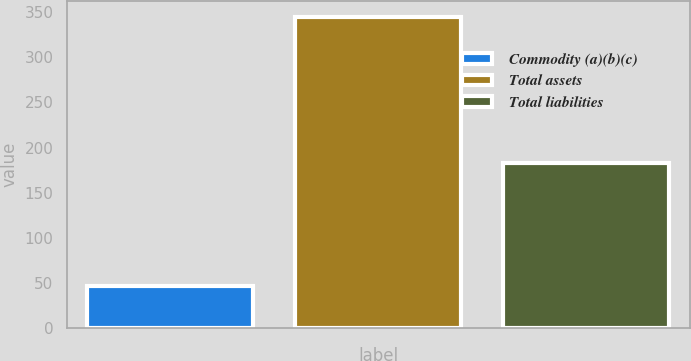Convert chart to OTSL. <chart><loc_0><loc_0><loc_500><loc_500><bar_chart><fcel>Commodity (a)(b)(c)<fcel>Total assets<fcel>Total liabilities<nl><fcel>47<fcel>345<fcel>183<nl></chart> 